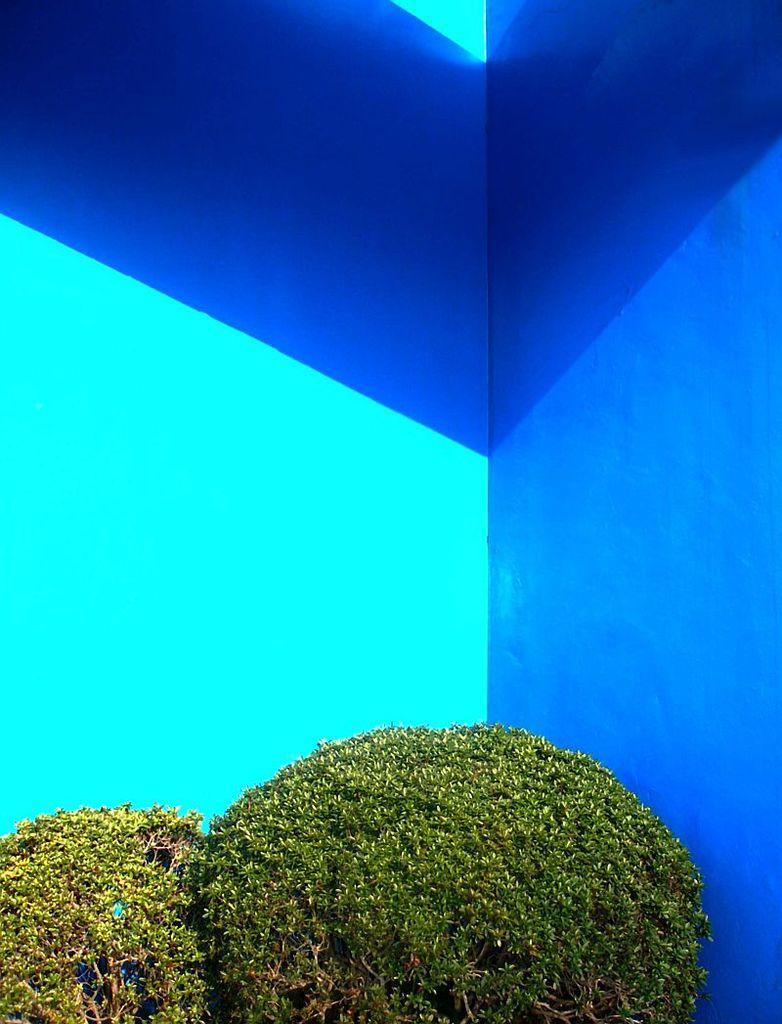Please provide a concise description of this image. In this picture we can see shrubs here, in the background we can see a wall. 